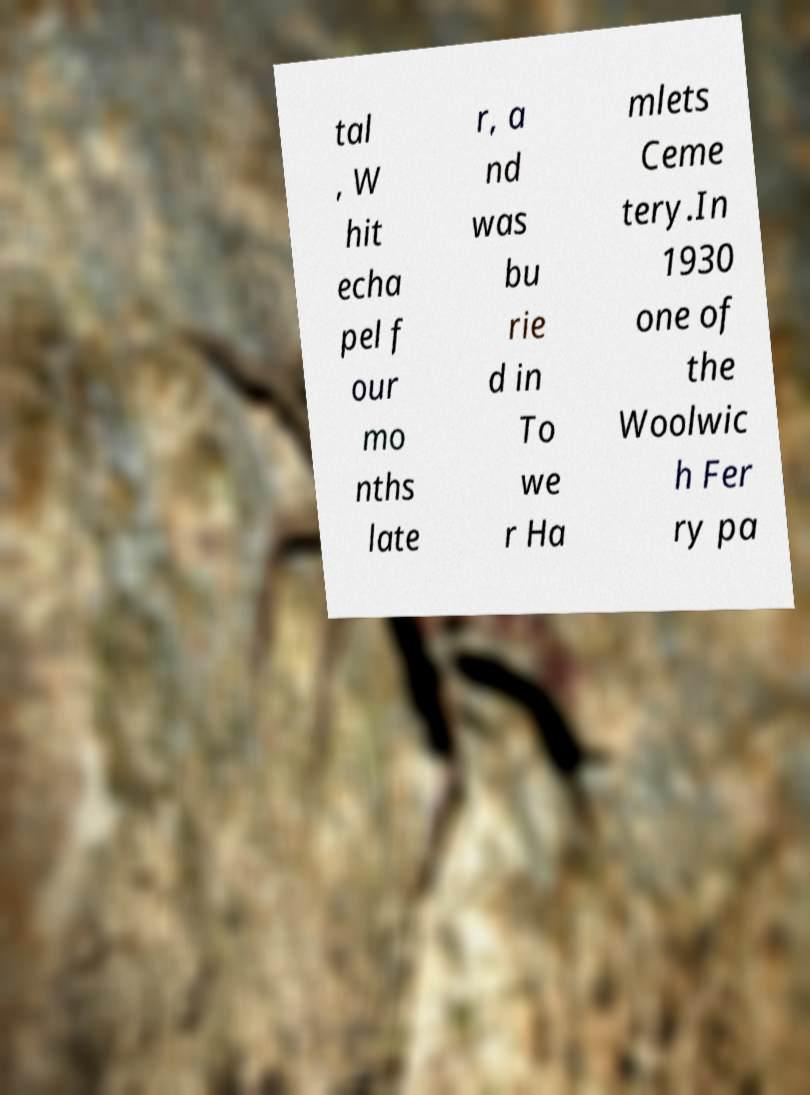There's text embedded in this image that I need extracted. Can you transcribe it verbatim? tal , W hit echa pel f our mo nths late r, a nd was bu rie d in To we r Ha mlets Ceme tery.In 1930 one of the Woolwic h Fer ry pa 